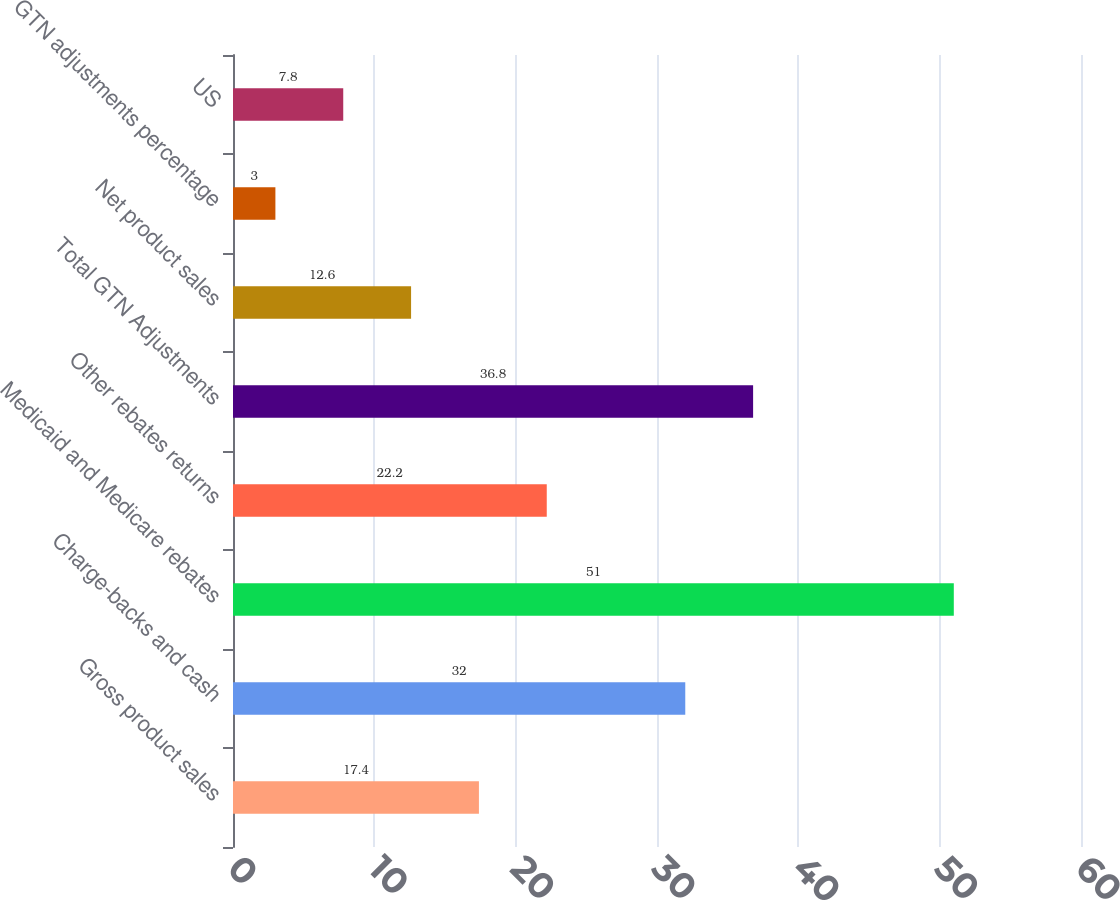Convert chart to OTSL. <chart><loc_0><loc_0><loc_500><loc_500><bar_chart><fcel>Gross product sales<fcel>Charge-backs and cash<fcel>Medicaid and Medicare rebates<fcel>Other rebates returns<fcel>Total GTN Adjustments<fcel>Net product sales<fcel>GTN adjustments percentage<fcel>US<nl><fcel>17.4<fcel>32<fcel>51<fcel>22.2<fcel>36.8<fcel>12.6<fcel>3<fcel>7.8<nl></chart> 